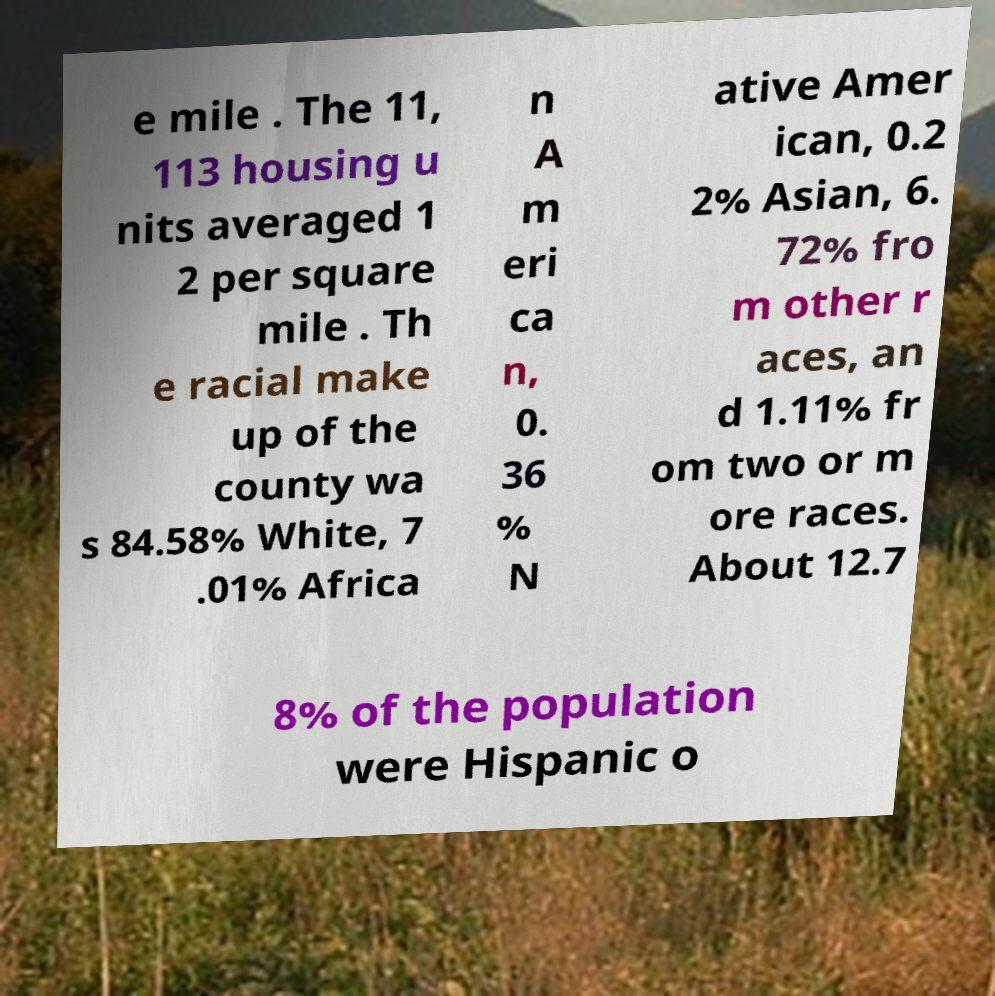Can you read and provide the text displayed in the image?This photo seems to have some interesting text. Can you extract and type it out for me? e mile . The 11, 113 housing u nits averaged 1 2 per square mile . Th e racial make up of the county wa s 84.58% White, 7 .01% Africa n A m eri ca n, 0. 36 % N ative Amer ican, 0.2 2% Asian, 6. 72% fro m other r aces, an d 1.11% fr om two or m ore races. About 12.7 8% of the population were Hispanic o 